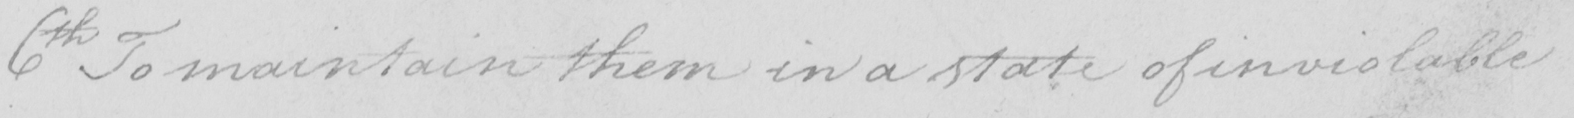Can you read and transcribe this handwriting? 6th To maintain them in a state of inviolable 